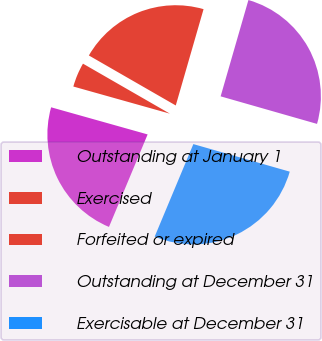<chart> <loc_0><loc_0><loc_500><loc_500><pie_chart><fcel>Outstanding at January 1<fcel>Exercised<fcel>Forfeited or expired<fcel>Outstanding at December 31<fcel>Exercisable at December 31<nl><fcel>23.06%<fcel>3.95%<fcel>21.16%<fcel>24.96%<fcel>26.87%<nl></chart> 